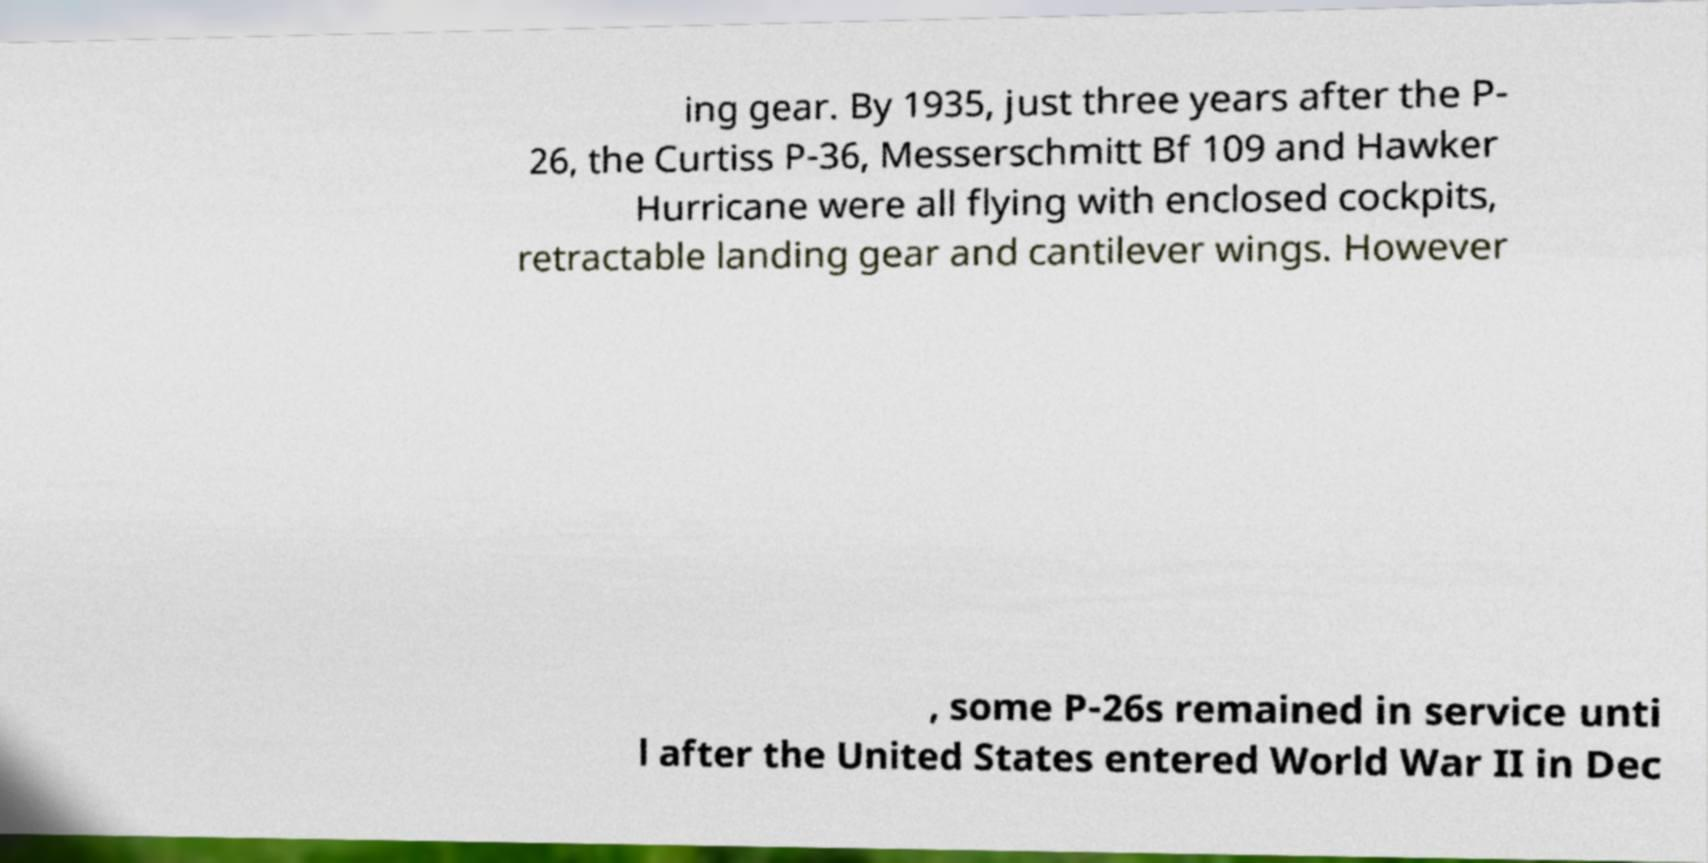For documentation purposes, I need the text within this image transcribed. Could you provide that? ing gear. By 1935, just three years after the P- 26, the Curtiss P-36, Messerschmitt Bf 109 and Hawker Hurricane were all flying with enclosed cockpits, retractable landing gear and cantilever wings. However , some P-26s remained in service unti l after the United States entered World War II in Dec 